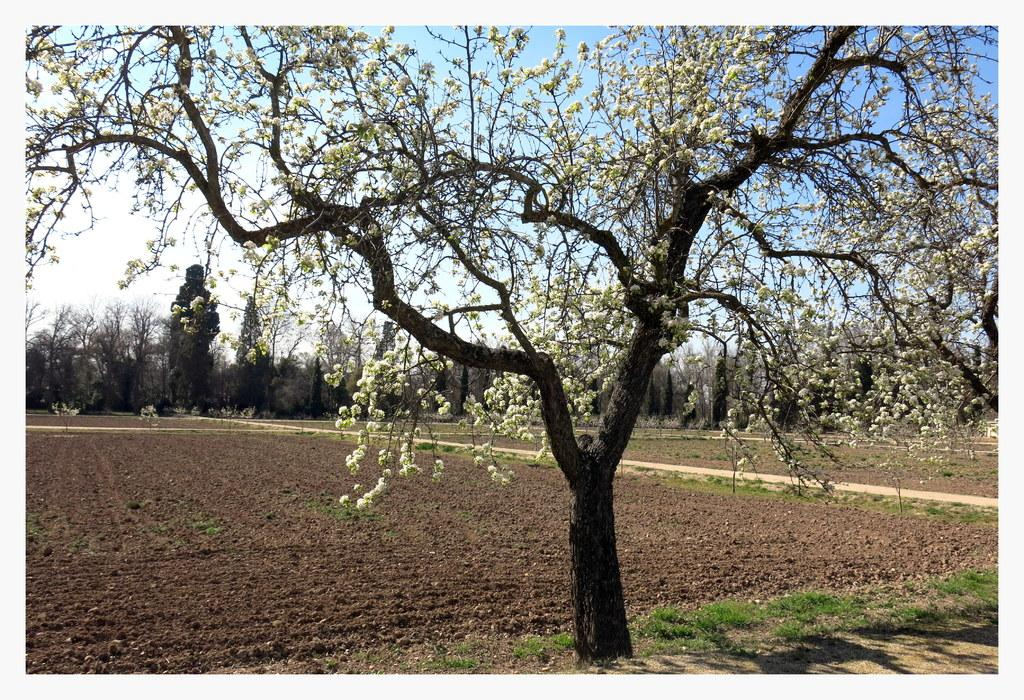What type of vegetation can be seen in the image? There are trees and grass visible in the image. What color are the flowers in the image? The flowers in the image are white. What is the ground made of in the image? Soil is visible in the image. What is visible in the background of the image? The sky is visible in the background of the image. What type of animal is sitting on the desk in the image? There is no desk or animal present in the image. 